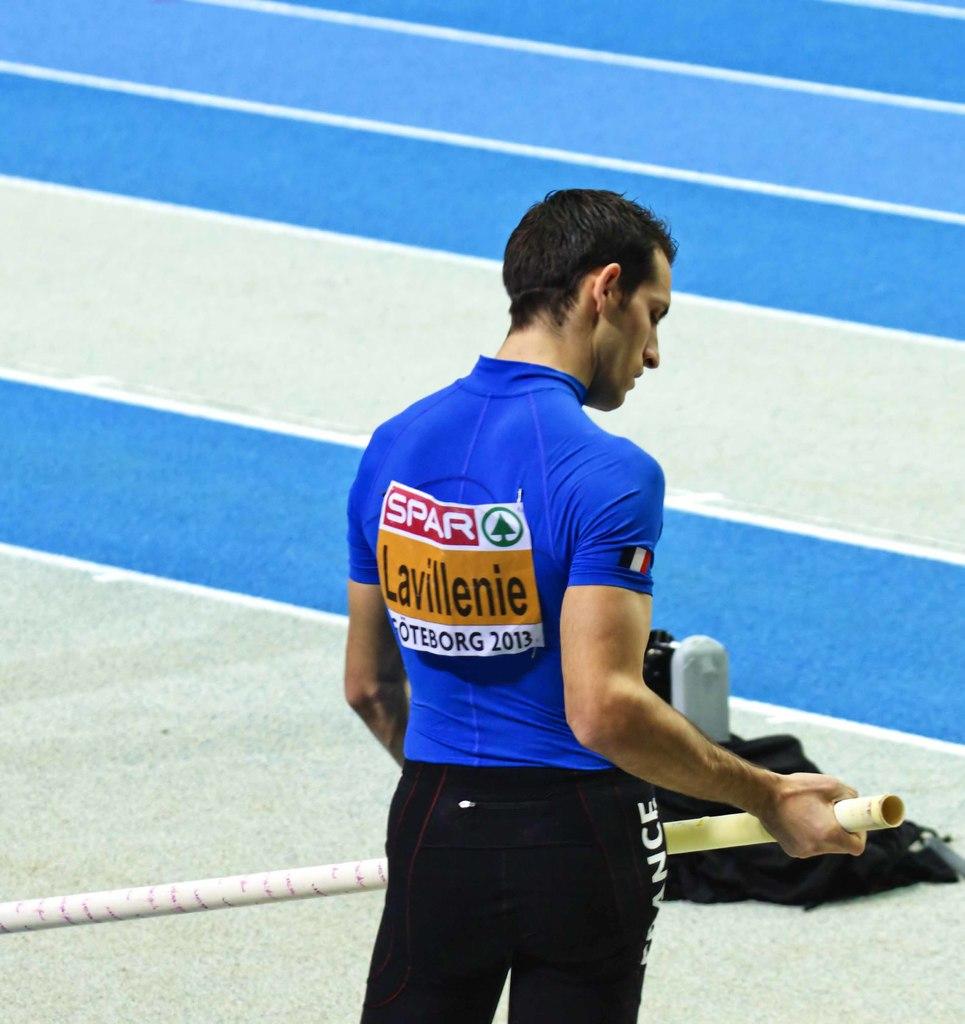What is written in the orange box?
Provide a short and direct response. Lavillenie. 